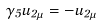Convert formula to latex. <formula><loc_0><loc_0><loc_500><loc_500>\gamma _ { 5 } u _ { 2 \mu } = - u _ { 2 \mu }</formula> 